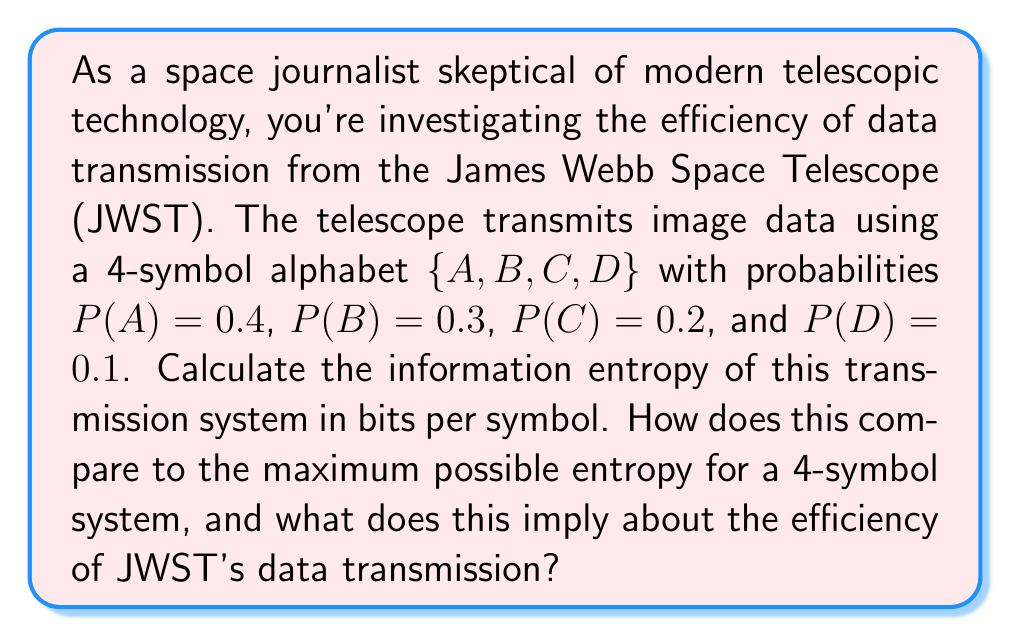Could you help me with this problem? To calculate the information entropy of the JWST's transmission system, we'll use the formula for Shannon entropy:

$$H = -\sum_{i=1}^n p_i \log_2(p_i)$$

where $p_i$ is the probability of each symbol, and $n$ is the number of symbols in the alphabet.

Step 1: Calculate the entropy contribution of each symbol:
* For A: $-0.4 \log_2(0.4) = 0.528$ bits
* For B: $-0.3 \log_2(0.3) = 0.521$ bits
* For C: $-0.2 \log_2(0.2) = 0.464$ bits
* For D: $-0.1 \log_2(0.1) = 0.332$ bits

Step 2: Sum these values to get the total entropy:
$$H = 0.528 + 0.521 + 0.464 + 0.332 = 1.845$$ bits per symbol

Step 3: Calculate the maximum possible entropy for a 4-symbol system:
The maximum entropy occurs when all symbols are equally probable, i.e., $p_i = \frac{1}{4} = 0.25$ for all $i$.
$$H_{max} = -4 \cdot (0.25 \log_2(0.25)) = 2$$ bits per symbol

Step 4: Compare the actual entropy to the maximum possible entropy:
Efficiency = $\frac{1.845}{2} \cdot 100\% = 92.25\%$

This high efficiency implies that despite your skepticism, the JWST's data transmission system is well-optimized, utilizing 92.25% of the theoretical maximum information capacity for a 4-symbol system.
Answer: The information entropy of the JWST's transmission system is 1.845 bits per symbol, which is 92.25% of the maximum possible entropy (2 bits per symbol) for a 4-symbol system. This indicates a highly efficient data transmission method, challenging the notion that modern telescopic technology is becoming irrelevant. 